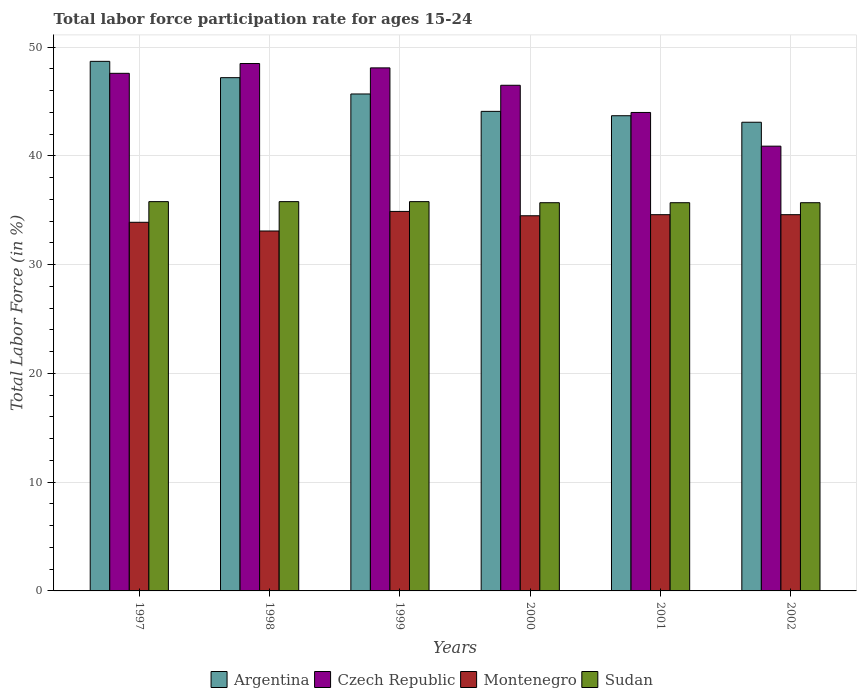How many groups of bars are there?
Your answer should be compact. 6. Are the number of bars on each tick of the X-axis equal?
Your response must be concise. Yes. What is the label of the 5th group of bars from the left?
Keep it short and to the point. 2001. Across all years, what is the maximum labor force participation rate in Montenegro?
Provide a short and direct response. 34.9. Across all years, what is the minimum labor force participation rate in Sudan?
Offer a terse response. 35.7. What is the total labor force participation rate in Sudan in the graph?
Give a very brief answer. 214.5. What is the difference between the labor force participation rate in Sudan in 1998 and that in 2002?
Give a very brief answer. 0.1. What is the difference between the labor force participation rate in Montenegro in 1998 and the labor force participation rate in Czech Republic in 2001?
Your answer should be very brief. -10.9. What is the average labor force participation rate in Czech Republic per year?
Provide a short and direct response. 45.93. In the year 1997, what is the difference between the labor force participation rate in Czech Republic and labor force participation rate in Argentina?
Your answer should be compact. -1.1. In how many years, is the labor force participation rate in Czech Republic greater than 24 %?
Your answer should be compact. 6. What is the ratio of the labor force participation rate in Montenegro in 1997 to that in 2000?
Your answer should be compact. 0.98. Is the difference between the labor force participation rate in Czech Republic in 1999 and 2002 greater than the difference between the labor force participation rate in Argentina in 1999 and 2002?
Provide a succinct answer. Yes. What is the difference between the highest and the second highest labor force participation rate in Argentina?
Provide a short and direct response. 1.5. What is the difference between the highest and the lowest labor force participation rate in Argentina?
Your response must be concise. 5.6. What does the 2nd bar from the left in 2002 represents?
Provide a succinct answer. Czech Republic. What does the 3rd bar from the right in 2000 represents?
Make the answer very short. Czech Republic. How many years are there in the graph?
Ensure brevity in your answer.  6. Does the graph contain any zero values?
Provide a succinct answer. No. Where does the legend appear in the graph?
Your answer should be very brief. Bottom center. How are the legend labels stacked?
Your answer should be very brief. Horizontal. What is the title of the graph?
Offer a terse response. Total labor force participation rate for ages 15-24. What is the label or title of the Y-axis?
Your answer should be very brief. Total Labor Force (in %). What is the Total Labor Force (in %) in Argentina in 1997?
Ensure brevity in your answer.  48.7. What is the Total Labor Force (in %) of Czech Republic in 1997?
Give a very brief answer. 47.6. What is the Total Labor Force (in %) in Montenegro in 1997?
Your answer should be very brief. 33.9. What is the Total Labor Force (in %) in Sudan in 1997?
Keep it short and to the point. 35.8. What is the Total Labor Force (in %) in Argentina in 1998?
Offer a very short reply. 47.2. What is the Total Labor Force (in %) of Czech Republic in 1998?
Make the answer very short. 48.5. What is the Total Labor Force (in %) in Montenegro in 1998?
Provide a succinct answer. 33.1. What is the Total Labor Force (in %) of Sudan in 1998?
Keep it short and to the point. 35.8. What is the Total Labor Force (in %) in Argentina in 1999?
Your response must be concise. 45.7. What is the Total Labor Force (in %) of Czech Republic in 1999?
Keep it short and to the point. 48.1. What is the Total Labor Force (in %) of Montenegro in 1999?
Make the answer very short. 34.9. What is the Total Labor Force (in %) of Sudan in 1999?
Make the answer very short. 35.8. What is the Total Labor Force (in %) in Argentina in 2000?
Offer a very short reply. 44.1. What is the Total Labor Force (in %) of Czech Republic in 2000?
Offer a terse response. 46.5. What is the Total Labor Force (in %) in Montenegro in 2000?
Ensure brevity in your answer.  34.5. What is the Total Labor Force (in %) in Sudan in 2000?
Your answer should be very brief. 35.7. What is the Total Labor Force (in %) of Argentina in 2001?
Your answer should be compact. 43.7. What is the Total Labor Force (in %) of Czech Republic in 2001?
Your answer should be compact. 44. What is the Total Labor Force (in %) in Montenegro in 2001?
Your answer should be compact. 34.6. What is the Total Labor Force (in %) in Sudan in 2001?
Make the answer very short. 35.7. What is the Total Labor Force (in %) of Argentina in 2002?
Offer a very short reply. 43.1. What is the Total Labor Force (in %) of Czech Republic in 2002?
Your response must be concise. 40.9. What is the Total Labor Force (in %) in Montenegro in 2002?
Keep it short and to the point. 34.6. What is the Total Labor Force (in %) of Sudan in 2002?
Offer a terse response. 35.7. Across all years, what is the maximum Total Labor Force (in %) in Argentina?
Your response must be concise. 48.7. Across all years, what is the maximum Total Labor Force (in %) of Czech Republic?
Offer a terse response. 48.5. Across all years, what is the maximum Total Labor Force (in %) in Montenegro?
Provide a short and direct response. 34.9. Across all years, what is the maximum Total Labor Force (in %) of Sudan?
Your answer should be very brief. 35.8. Across all years, what is the minimum Total Labor Force (in %) of Argentina?
Offer a terse response. 43.1. Across all years, what is the minimum Total Labor Force (in %) in Czech Republic?
Your response must be concise. 40.9. Across all years, what is the minimum Total Labor Force (in %) of Montenegro?
Ensure brevity in your answer.  33.1. Across all years, what is the minimum Total Labor Force (in %) of Sudan?
Keep it short and to the point. 35.7. What is the total Total Labor Force (in %) of Argentina in the graph?
Provide a succinct answer. 272.5. What is the total Total Labor Force (in %) in Czech Republic in the graph?
Offer a terse response. 275.6. What is the total Total Labor Force (in %) in Montenegro in the graph?
Your answer should be compact. 205.6. What is the total Total Labor Force (in %) of Sudan in the graph?
Provide a short and direct response. 214.5. What is the difference between the Total Labor Force (in %) of Montenegro in 1997 and that in 1998?
Ensure brevity in your answer.  0.8. What is the difference between the Total Labor Force (in %) of Argentina in 1997 and that in 1999?
Your answer should be compact. 3. What is the difference between the Total Labor Force (in %) in Czech Republic in 1997 and that in 1999?
Offer a terse response. -0.5. What is the difference between the Total Labor Force (in %) in Montenegro in 1997 and that in 1999?
Keep it short and to the point. -1. What is the difference between the Total Labor Force (in %) of Sudan in 1997 and that in 1999?
Offer a terse response. 0. What is the difference between the Total Labor Force (in %) of Argentina in 1997 and that in 2000?
Your response must be concise. 4.6. What is the difference between the Total Labor Force (in %) of Czech Republic in 1997 and that in 2000?
Offer a terse response. 1.1. What is the difference between the Total Labor Force (in %) of Argentina in 1997 and that in 2001?
Make the answer very short. 5. What is the difference between the Total Labor Force (in %) of Argentina in 1997 and that in 2002?
Ensure brevity in your answer.  5.6. What is the difference between the Total Labor Force (in %) of Czech Republic in 1997 and that in 2002?
Provide a succinct answer. 6.7. What is the difference between the Total Labor Force (in %) of Montenegro in 1997 and that in 2002?
Your answer should be very brief. -0.7. What is the difference between the Total Labor Force (in %) in Sudan in 1997 and that in 2002?
Offer a very short reply. 0.1. What is the difference between the Total Labor Force (in %) of Argentina in 1998 and that in 1999?
Offer a very short reply. 1.5. What is the difference between the Total Labor Force (in %) of Montenegro in 1998 and that in 1999?
Offer a terse response. -1.8. What is the difference between the Total Labor Force (in %) of Sudan in 1998 and that in 2000?
Your response must be concise. 0.1. What is the difference between the Total Labor Force (in %) in Montenegro in 1998 and that in 2001?
Your response must be concise. -1.5. What is the difference between the Total Labor Force (in %) of Argentina in 1998 and that in 2002?
Your response must be concise. 4.1. What is the difference between the Total Labor Force (in %) of Czech Republic in 1998 and that in 2002?
Offer a terse response. 7.6. What is the difference between the Total Labor Force (in %) in Sudan in 1998 and that in 2002?
Your response must be concise. 0.1. What is the difference between the Total Labor Force (in %) in Czech Republic in 1999 and that in 2000?
Your answer should be compact. 1.6. What is the difference between the Total Labor Force (in %) in Argentina in 1999 and that in 2001?
Make the answer very short. 2. What is the difference between the Total Labor Force (in %) of Czech Republic in 1999 and that in 2001?
Offer a terse response. 4.1. What is the difference between the Total Labor Force (in %) in Czech Republic in 1999 and that in 2002?
Make the answer very short. 7.2. What is the difference between the Total Labor Force (in %) of Montenegro in 1999 and that in 2002?
Keep it short and to the point. 0.3. What is the difference between the Total Labor Force (in %) of Sudan in 1999 and that in 2002?
Ensure brevity in your answer.  0.1. What is the difference between the Total Labor Force (in %) in Argentina in 2000 and that in 2001?
Offer a very short reply. 0.4. What is the difference between the Total Labor Force (in %) of Sudan in 2000 and that in 2001?
Offer a terse response. 0. What is the difference between the Total Labor Force (in %) of Czech Republic in 2000 and that in 2002?
Offer a terse response. 5.6. What is the difference between the Total Labor Force (in %) of Sudan in 2000 and that in 2002?
Give a very brief answer. 0. What is the difference between the Total Labor Force (in %) of Czech Republic in 2001 and that in 2002?
Ensure brevity in your answer.  3.1. What is the difference between the Total Labor Force (in %) of Argentina in 1997 and the Total Labor Force (in %) of Czech Republic in 1998?
Your answer should be very brief. 0.2. What is the difference between the Total Labor Force (in %) of Argentina in 1997 and the Total Labor Force (in %) of Sudan in 1998?
Ensure brevity in your answer.  12.9. What is the difference between the Total Labor Force (in %) in Czech Republic in 1997 and the Total Labor Force (in %) in Montenegro in 1999?
Ensure brevity in your answer.  12.7. What is the difference between the Total Labor Force (in %) of Czech Republic in 1997 and the Total Labor Force (in %) of Sudan in 1999?
Give a very brief answer. 11.8. What is the difference between the Total Labor Force (in %) of Montenegro in 1997 and the Total Labor Force (in %) of Sudan in 1999?
Ensure brevity in your answer.  -1.9. What is the difference between the Total Labor Force (in %) of Argentina in 1997 and the Total Labor Force (in %) of Czech Republic in 2000?
Keep it short and to the point. 2.2. What is the difference between the Total Labor Force (in %) in Argentina in 1997 and the Total Labor Force (in %) in Montenegro in 2000?
Offer a terse response. 14.2. What is the difference between the Total Labor Force (in %) in Czech Republic in 1997 and the Total Labor Force (in %) in Montenegro in 2000?
Give a very brief answer. 13.1. What is the difference between the Total Labor Force (in %) of Argentina in 1997 and the Total Labor Force (in %) of Czech Republic in 2001?
Provide a succinct answer. 4.7. What is the difference between the Total Labor Force (in %) of Czech Republic in 1997 and the Total Labor Force (in %) of Montenegro in 2001?
Your answer should be very brief. 13. What is the difference between the Total Labor Force (in %) in Argentina in 1997 and the Total Labor Force (in %) in Czech Republic in 2002?
Give a very brief answer. 7.8. What is the difference between the Total Labor Force (in %) in Argentina in 1997 and the Total Labor Force (in %) in Montenegro in 2002?
Provide a short and direct response. 14.1. What is the difference between the Total Labor Force (in %) of Argentina in 1997 and the Total Labor Force (in %) of Sudan in 2002?
Offer a terse response. 13. What is the difference between the Total Labor Force (in %) of Czech Republic in 1997 and the Total Labor Force (in %) of Montenegro in 2002?
Offer a very short reply. 13. What is the difference between the Total Labor Force (in %) in Argentina in 1998 and the Total Labor Force (in %) in Montenegro in 1999?
Your answer should be very brief. 12.3. What is the difference between the Total Labor Force (in %) in Czech Republic in 1998 and the Total Labor Force (in %) in Sudan in 1999?
Keep it short and to the point. 12.7. What is the difference between the Total Labor Force (in %) of Argentina in 1998 and the Total Labor Force (in %) of Czech Republic in 2000?
Your answer should be very brief. 0.7. What is the difference between the Total Labor Force (in %) of Argentina in 1998 and the Total Labor Force (in %) of Montenegro in 2000?
Provide a succinct answer. 12.7. What is the difference between the Total Labor Force (in %) in Argentina in 1998 and the Total Labor Force (in %) in Sudan in 2000?
Offer a very short reply. 11.5. What is the difference between the Total Labor Force (in %) in Czech Republic in 1998 and the Total Labor Force (in %) in Sudan in 2000?
Make the answer very short. 12.8. What is the difference between the Total Labor Force (in %) of Argentina in 1998 and the Total Labor Force (in %) of Czech Republic in 2001?
Offer a terse response. 3.2. What is the difference between the Total Labor Force (in %) in Argentina in 1998 and the Total Labor Force (in %) in Montenegro in 2001?
Your response must be concise. 12.6. What is the difference between the Total Labor Force (in %) of Argentina in 1998 and the Total Labor Force (in %) of Sudan in 2001?
Provide a short and direct response. 11.5. What is the difference between the Total Labor Force (in %) of Czech Republic in 1998 and the Total Labor Force (in %) of Montenegro in 2001?
Provide a short and direct response. 13.9. What is the difference between the Total Labor Force (in %) of Czech Republic in 1998 and the Total Labor Force (in %) of Sudan in 2001?
Keep it short and to the point. 12.8. What is the difference between the Total Labor Force (in %) in Czech Republic in 1998 and the Total Labor Force (in %) in Montenegro in 2002?
Your answer should be very brief. 13.9. What is the difference between the Total Labor Force (in %) of Argentina in 1999 and the Total Labor Force (in %) of Montenegro in 2000?
Keep it short and to the point. 11.2. What is the difference between the Total Labor Force (in %) of Argentina in 1999 and the Total Labor Force (in %) of Czech Republic in 2001?
Keep it short and to the point. 1.7. What is the difference between the Total Labor Force (in %) in Argentina in 1999 and the Total Labor Force (in %) in Montenegro in 2001?
Ensure brevity in your answer.  11.1. What is the difference between the Total Labor Force (in %) in Argentina in 1999 and the Total Labor Force (in %) in Sudan in 2001?
Offer a very short reply. 10. What is the difference between the Total Labor Force (in %) in Montenegro in 1999 and the Total Labor Force (in %) in Sudan in 2001?
Offer a terse response. -0.8. What is the difference between the Total Labor Force (in %) in Argentina in 1999 and the Total Labor Force (in %) in Czech Republic in 2002?
Ensure brevity in your answer.  4.8. What is the difference between the Total Labor Force (in %) of Czech Republic in 1999 and the Total Labor Force (in %) of Sudan in 2002?
Your answer should be very brief. 12.4. What is the difference between the Total Labor Force (in %) in Montenegro in 2000 and the Total Labor Force (in %) in Sudan in 2001?
Offer a very short reply. -1.2. What is the difference between the Total Labor Force (in %) in Czech Republic in 2000 and the Total Labor Force (in %) in Montenegro in 2002?
Ensure brevity in your answer.  11.9. What is the difference between the Total Labor Force (in %) in Czech Republic in 2000 and the Total Labor Force (in %) in Sudan in 2002?
Your response must be concise. 10.8. What is the difference between the Total Labor Force (in %) of Montenegro in 2000 and the Total Labor Force (in %) of Sudan in 2002?
Your answer should be very brief. -1.2. What is the difference between the Total Labor Force (in %) in Argentina in 2001 and the Total Labor Force (in %) in Montenegro in 2002?
Your response must be concise. 9.1. What is the difference between the Total Labor Force (in %) in Argentina in 2001 and the Total Labor Force (in %) in Sudan in 2002?
Your response must be concise. 8. What is the difference between the Total Labor Force (in %) of Czech Republic in 2001 and the Total Labor Force (in %) of Montenegro in 2002?
Make the answer very short. 9.4. What is the difference between the Total Labor Force (in %) of Czech Republic in 2001 and the Total Labor Force (in %) of Sudan in 2002?
Give a very brief answer. 8.3. What is the difference between the Total Labor Force (in %) of Montenegro in 2001 and the Total Labor Force (in %) of Sudan in 2002?
Offer a terse response. -1.1. What is the average Total Labor Force (in %) in Argentina per year?
Your answer should be very brief. 45.42. What is the average Total Labor Force (in %) of Czech Republic per year?
Ensure brevity in your answer.  45.93. What is the average Total Labor Force (in %) of Montenegro per year?
Offer a terse response. 34.27. What is the average Total Labor Force (in %) of Sudan per year?
Offer a very short reply. 35.75. In the year 1997, what is the difference between the Total Labor Force (in %) in Czech Republic and Total Labor Force (in %) in Montenegro?
Your answer should be compact. 13.7. In the year 1997, what is the difference between the Total Labor Force (in %) of Montenegro and Total Labor Force (in %) of Sudan?
Provide a succinct answer. -1.9. In the year 1998, what is the difference between the Total Labor Force (in %) in Argentina and Total Labor Force (in %) in Montenegro?
Provide a short and direct response. 14.1. In the year 1998, what is the difference between the Total Labor Force (in %) in Czech Republic and Total Labor Force (in %) in Montenegro?
Your answer should be compact. 15.4. In the year 1998, what is the difference between the Total Labor Force (in %) of Czech Republic and Total Labor Force (in %) of Sudan?
Provide a succinct answer. 12.7. In the year 1998, what is the difference between the Total Labor Force (in %) of Montenegro and Total Labor Force (in %) of Sudan?
Your response must be concise. -2.7. In the year 1999, what is the difference between the Total Labor Force (in %) of Argentina and Total Labor Force (in %) of Montenegro?
Ensure brevity in your answer.  10.8. In the year 1999, what is the difference between the Total Labor Force (in %) in Argentina and Total Labor Force (in %) in Sudan?
Give a very brief answer. 9.9. In the year 1999, what is the difference between the Total Labor Force (in %) of Montenegro and Total Labor Force (in %) of Sudan?
Provide a succinct answer. -0.9. In the year 2000, what is the difference between the Total Labor Force (in %) of Argentina and Total Labor Force (in %) of Sudan?
Your response must be concise. 8.4. In the year 2000, what is the difference between the Total Labor Force (in %) of Czech Republic and Total Labor Force (in %) of Montenegro?
Provide a succinct answer. 12. In the year 2001, what is the difference between the Total Labor Force (in %) of Czech Republic and Total Labor Force (in %) of Sudan?
Offer a terse response. 8.3. In the year 2001, what is the difference between the Total Labor Force (in %) of Montenegro and Total Labor Force (in %) of Sudan?
Keep it short and to the point. -1.1. In the year 2002, what is the difference between the Total Labor Force (in %) in Czech Republic and Total Labor Force (in %) in Montenegro?
Make the answer very short. 6.3. What is the ratio of the Total Labor Force (in %) of Argentina in 1997 to that in 1998?
Make the answer very short. 1.03. What is the ratio of the Total Labor Force (in %) of Czech Republic in 1997 to that in 1998?
Your response must be concise. 0.98. What is the ratio of the Total Labor Force (in %) of Montenegro in 1997 to that in 1998?
Provide a succinct answer. 1.02. What is the ratio of the Total Labor Force (in %) in Sudan in 1997 to that in 1998?
Your response must be concise. 1. What is the ratio of the Total Labor Force (in %) of Argentina in 1997 to that in 1999?
Provide a short and direct response. 1.07. What is the ratio of the Total Labor Force (in %) of Czech Republic in 1997 to that in 1999?
Keep it short and to the point. 0.99. What is the ratio of the Total Labor Force (in %) of Montenegro in 1997 to that in 1999?
Your answer should be very brief. 0.97. What is the ratio of the Total Labor Force (in %) of Sudan in 1997 to that in 1999?
Offer a very short reply. 1. What is the ratio of the Total Labor Force (in %) in Argentina in 1997 to that in 2000?
Keep it short and to the point. 1.1. What is the ratio of the Total Labor Force (in %) in Czech Republic in 1997 to that in 2000?
Ensure brevity in your answer.  1.02. What is the ratio of the Total Labor Force (in %) of Montenegro in 1997 to that in 2000?
Give a very brief answer. 0.98. What is the ratio of the Total Labor Force (in %) of Sudan in 1997 to that in 2000?
Provide a short and direct response. 1. What is the ratio of the Total Labor Force (in %) of Argentina in 1997 to that in 2001?
Make the answer very short. 1.11. What is the ratio of the Total Labor Force (in %) of Czech Republic in 1997 to that in 2001?
Your response must be concise. 1.08. What is the ratio of the Total Labor Force (in %) in Montenegro in 1997 to that in 2001?
Offer a terse response. 0.98. What is the ratio of the Total Labor Force (in %) in Sudan in 1997 to that in 2001?
Keep it short and to the point. 1. What is the ratio of the Total Labor Force (in %) in Argentina in 1997 to that in 2002?
Your answer should be compact. 1.13. What is the ratio of the Total Labor Force (in %) of Czech Republic in 1997 to that in 2002?
Offer a very short reply. 1.16. What is the ratio of the Total Labor Force (in %) in Montenegro in 1997 to that in 2002?
Offer a very short reply. 0.98. What is the ratio of the Total Labor Force (in %) of Argentina in 1998 to that in 1999?
Give a very brief answer. 1.03. What is the ratio of the Total Labor Force (in %) of Czech Republic in 1998 to that in 1999?
Offer a terse response. 1.01. What is the ratio of the Total Labor Force (in %) of Montenegro in 1998 to that in 1999?
Provide a short and direct response. 0.95. What is the ratio of the Total Labor Force (in %) of Sudan in 1998 to that in 1999?
Provide a short and direct response. 1. What is the ratio of the Total Labor Force (in %) of Argentina in 1998 to that in 2000?
Provide a succinct answer. 1.07. What is the ratio of the Total Labor Force (in %) of Czech Republic in 1998 to that in 2000?
Make the answer very short. 1.04. What is the ratio of the Total Labor Force (in %) in Montenegro in 1998 to that in 2000?
Offer a very short reply. 0.96. What is the ratio of the Total Labor Force (in %) in Argentina in 1998 to that in 2001?
Make the answer very short. 1.08. What is the ratio of the Total Labor Force (in %) of Czech Republic in 1998 to that in 2001?
Offer a very short reply. 1.1. What is the ratio of the Total Labor Force (in %) in Montenegro in 1998 to that in 2001?
Give a very brief answer. 0.96. What is the ratio of the Total Labor Force (in %) of Argentina in 1998 to that in 2002?
Offer a very short reply. 1.1. What is the ratio of the Total Labor Force (in %) in Czech Republic in 1998 to that in 2002?
Ensure brevity in your answer.  1.19. What is the ratio of the Total Labor Force (in %) in Montenegro in 1998 to that in 2002?
Your answer should be compact. 0.96. What is the ratio of the Total Labor Force (in %) of Sudan in 1998 to that in 2002?
Ensure brevity in your answer.  1. What is the ratio of the Total Labor Force (in %) in Argentina in 1999 to that in 2000?
Your answer should be compact. 1.04. What is the ratio of the Total Labor Force (in %) of Czech Republic in 1999 to that in 2000?
Keep it short and to the point. 1.03. What is the ratio of the Total Labor Force (in %) of Montenegro in 1999 to that in 2000?
Provide a short and direct response. 1.01. What is the ratio of the Total Labor Force (in %) of Argentina in 1999 to that in 2001?
Your answer should be compact. 1.05. What is the ratio of the Total Labor Force (in %) of Czech Republic in 1999 to that in 2001?
Ensure brevity in your answer.  1.09. What is the ratio of the Total Labor Force (in %) of Montenegro in 1999 to that in 2001?
Offer a terse response. 1.01. What is the ratio of the Total Labor Force (in %) in Sudan in 1999 to that in 2001?
Your answer should be very brief. 1. What is the ratio of the Total Labor Force (in %) in Argentina in 1999 to that in 2002?
Provide a short and direct response. 1.06. What is the ratio of the Total Labor Force (in %) in Czech Republic in 1999 to that in 2002?
Provide a short and direct response. 1.18. What is the ratio of the Total Labor Force (in %) in Montenegro in 1999 to that in 2002?
Offer a very short reply. 1.01. What is the ratio of the Total Labor Force (in %) in Sudan in 1999 to that in 2002?
Provide a short and direct response. 1. What is the ratio of the Total Labor Force (in %) in Argentina in 2000 to that in 2001?
Your answer should be very brief. 1.01. What is the ratio of the Total Labor Force (in %) in Czech Republic in 2000 to that in 2001?
Your answer should be compact. 1.06. What is the ratio of the Total Labor Force (in %) in Sudan in 2000 to that in 2001?
Keep it short and to the point. 1. What is the ratio of the Total Labor Force (in %) of Argentina in 2000 to that in 2002?
Offer a terse response. 1.02. What is the ratio of the Total Labor Force (in %) in Czech Republic in 2000 to that in 2002?
Make the answer very short. 1.14. What is the ratio of the Total Labor Force (in %) in Montenegro in 2000 to that in 2002?
Provide a short and direct response. 1. What is the ratio of the Total Labor Force (in %) of Sudan in 2000 to that in 2002?
Your answer should be very brief. 1. What is the ratio of the Total Labor Force (in %) in Argentina in 2001 to that in 2002?
Offer a terse response. 1.01. What is the ratio of the Total Labor Force (in %) of Czech Republic in 2001 to that in 2002?
Your answer should be compact. 1.08. What is the ratio of the Total Labor Force (in %) in Montenegro in 2001 to that in 2002?
Provide a short and direct response. 1. What is the ratio of the Total Labor Force (in %) of Sudan in 2001 to that in 2002?
Ensure brevity in your answer.  1. What is the difference between the highest and the second highest Total Labor Force (in %) in Sudan?
Keep it short and to the point. 0. 